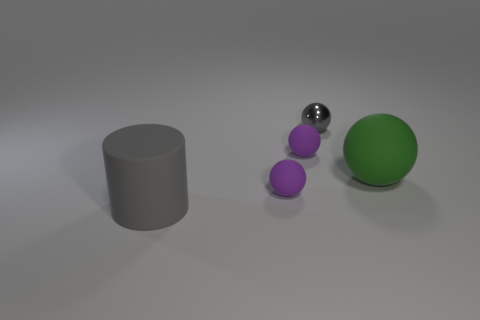Subtract 2 spheres. How many spheres are left? 2 Subtract all shiny balls. How many balls are left? 3 Add 2 gray things. How many objects exist? 7 Subtract all yellow balls. Subtract all purple cubes. How many balls are left? 4 Subtract all cylinders. How many objects are left? 4 Subtract 0 brown balls. How many objects are left? 5 Subtract all large cylinders. Subtract all matte things. How many objects are left? 0 Add 1 tiny matte balls. How many tiny matte balls are left? 3 Add 3 small purple things. How many small purple things exist? 5 